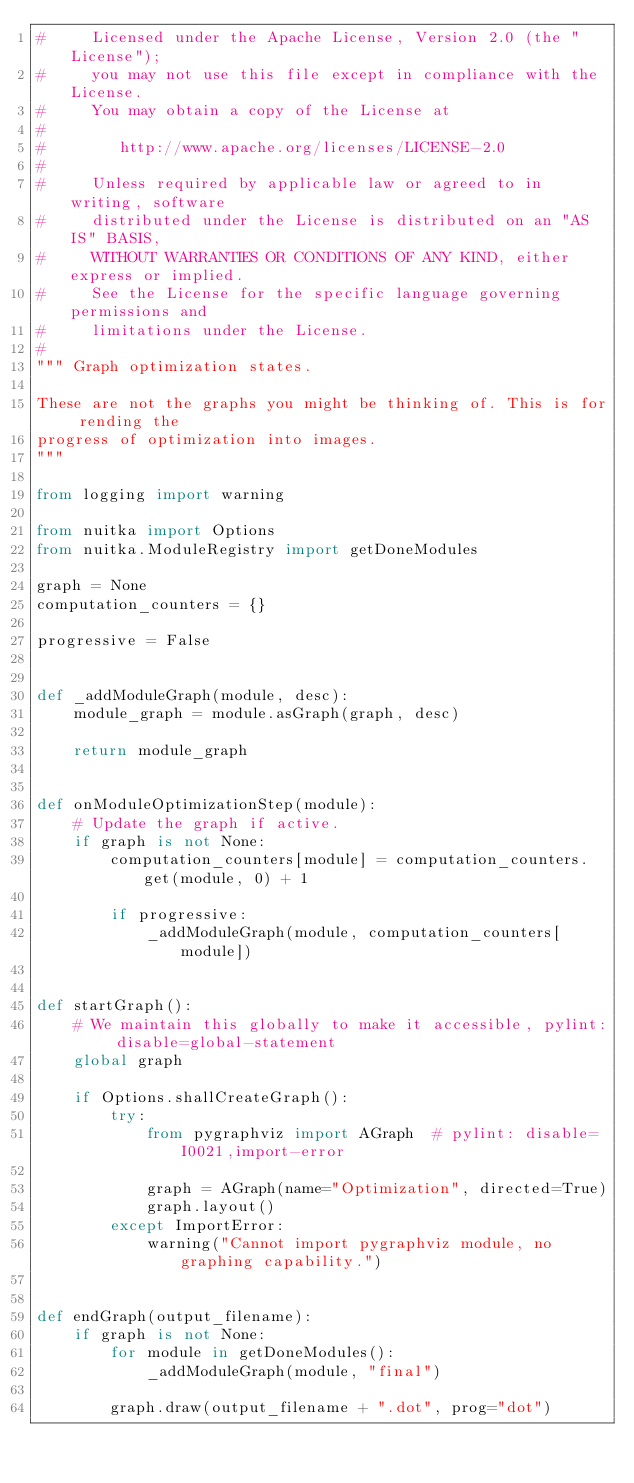<code> <loc_0><loc_0><loc_500><loc_500><_Python_>#     Licensed under the Apache License, Version 2.0 (the "License");
#     you may not use this file except in compliance with the License.
#     You may obtain a copy of the License at
#
#        http://www.apache.org/licenses/LICENSE-2.0
#
#     Unless required by applicable law or agreed to in writing, software
#     distributed under the License is distributed on an "AS IS" BASIS,
#     WITHOUT WARRANTIES OR CONDITIONS OF ANY KIND, either express or implied.
#     See the License for the specific language governing permissions and
#     limitations under the License.
#
""" Graph optimization states.

These are not the graphs you might be thinking of. This is for rending the
progress of optimization into images.
"""

from logging import warning

from nuitka import Options
from nuitka.ModuleRegistry import getDoneModules

graph = None
computation_counters = {}

progressive = False


def _addModuleGraph(module, desc):
    module_graph = module.asGraph(graph, desc)

    return module_graph


def onModuleOptimizationStep(module):
    # Update the graph if active.
    if graph is not None:
        computation_counters[module] = computation_counters.get(module, 0) + 1

        if progressive:
            _addModuleGraph(module, computation_counters[module])


def startGraph():
    # We maintain this globally to make it accessible, pylint: disable=global-statement
    global graph

    if Options.shallCreateGraph():
        try:
            from pygraphviz import AGraph  # pylint: disable=I0021,import-error

            graph = AGraph(name="Optimization", directed=True)
            graph.layout()
        except ImportError:
            warning("Cannot import pygraphviz module, no graphing capability.")


def endGraph(output_filename):
    if graph is not None:
        for module in getDoneModules():
            _addModuleGraph(module, "final")

        graph.draw(output_filename + ".dot", prog="dot")
</code> 